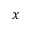Convert formula to latex. <formula><loc_0><loc_0><loc_500><loc_500>x</formula> 